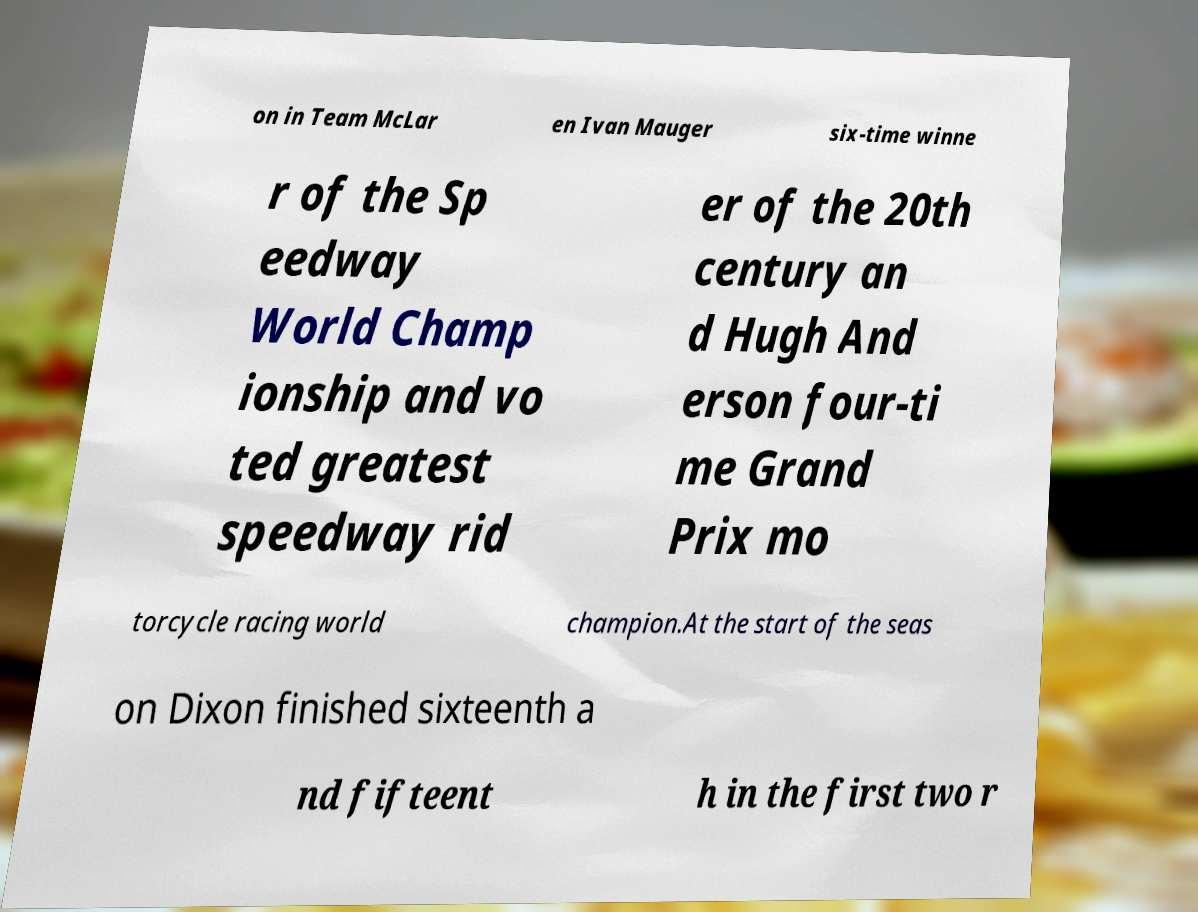There's text embedded in this image that I need extracted. Can you transcribe it verbatim? on in Team McLar en Ivan Mauger six-time winne r of the Sp eedway World Champ ionship and vo ted greatest speedway rid er of the 20th century an d Hugh And erson four-ti me Grand Prix mo torcycle racing world champion.At the start of the seas on Dixon finished sixteenth a nd fifteent h in the first two r 